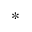Convert formula to latex. <formula><loc_0><loc_0><loc_500><loc_500>*</formula> 